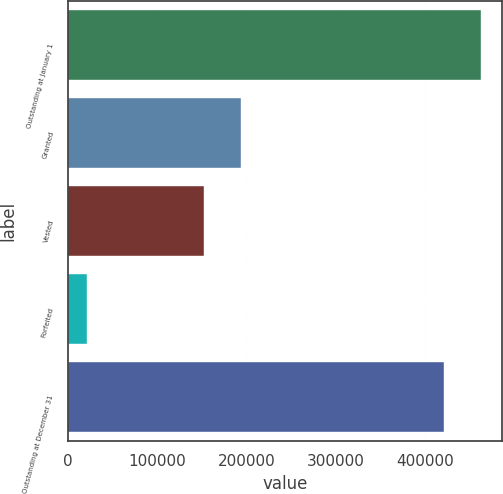<chart> <loc_0><loc_0><loc_500><loc_500><bar_chart><fcel>Outstanding at January 1<fcel>Granted<fcel>Vested<fcel>Forfeited<fcel>Outstanding at December 31<nl><fcel>462608<fcel>193744<fcel>152397<fcel>21865<fcel>421261<nl></chart> 